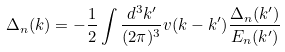<formula> <loc_0><loc_0><loc_500><loc_500>\Delta _ { n } ( k ) = - \frac { 1 } { 2 } \int \frac { d ^ { 3 } k ^ { \prime } } { ( 2 \pi ) ^ { 3 } } v ( k - k ^ { \prime } ) \frac { \Delta _ { n } ( k ^ { \prime } ) } { E _ { n } ( k ^ { \prime } ) }</formula> 